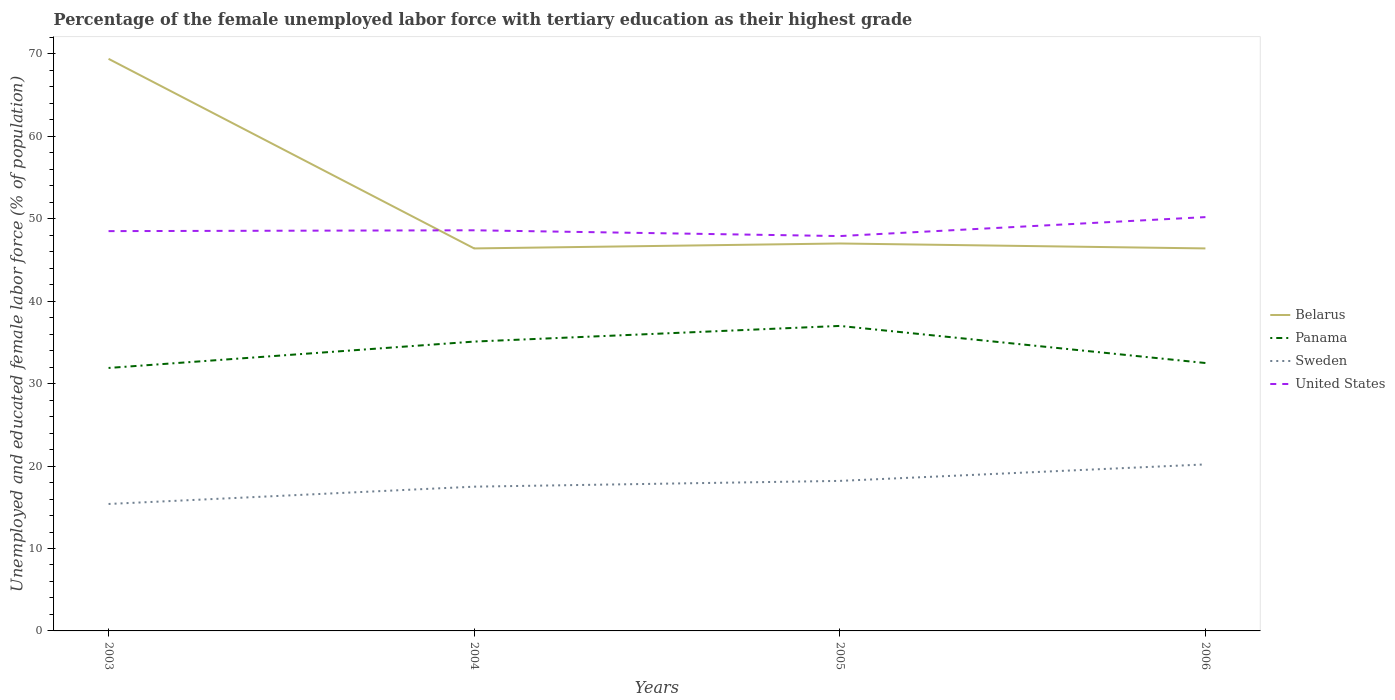How many different coloured lines are there?
Give a very brief answer. 4. Is the number of lines equal to the number of legend labels?
Make the answer very short. Yes. Across all years, what is the maximum percentage of the unemployed female labor force with tertiary education in United States?
Offer a terse response. 47.9. In which year was the percentage of the unemployed female labor force with tertiary education in Belarus maximum?
Your answer should be compact. 2004. What is the total percentage of the unemployed female labor force with tertiary education in Sweden in the graph?
Keep it short and to the point. -0.7. What is the difference between the highest and the second highest percentage of the unemployed female labor force with tertiary education in United States?
Make the answer very short. 2.3. What is the difference between the highest and the lowest percentage of the unemployed female labor force with tertiary education in Panama?
Your response must be concise. 2. Is the percentage of the unemployed female labor force with tertiary education in United States strictly greater than the percentage of the unemployed female labor force with tertiary education in Belarus over the years?
Your response must be concise. No. How many lines are there?
Offer a very short reply. 4. What is the difference between two consecutive major ticks on the Y-axis?
Your answer should be very brief. 10. Are the values on the major ticks of Y-axis written in scientific E-notation?
Keep it short and to the point. No. Does the graph contain any zero values?
Your answer should be compact. No. How are the legend labels stacked?
Ensure brevity in your answer.  Vertical. What is the title of the graph?
Your answer should be compact. Percentage of the female unemployed labor force with tertiary education as their highest grade. Does "Botswana" appear as one of the legend labels in the graph?
Your answer should be very brief. No. What is the label or title of the X-axis?
Keep it short and to the point. Years. What is the label or title of the Y-axis?
Make the answer very short. Unemployed and educated female labor force (% of population). What is the Unemployed and educated female labor force (% of population) of Belarus in 2003?
Provide a short and direct response. 69.4. What is the Unemployed and educated female labor force (% of population) of Panama in 2003?
Provide a short and direct response. 31.9. What is the Unemployed and educated female labor force (% of population) in Sweden in 2003?
Your answer should be very brief. 15.4. What is the Unemployed and educated female labor force (% of population) of United States in 2003?
Offer a terse response. 48.5. What is the Unemployed and educated female labor force (% of population) in Belarus in 2004?
Keep it short and to the point. 46.4. What is the Unemployed and educated female labor force (% of population) of Panama in 2004?
Provide a short and direct response. 35.1. What is the Unemployed and educated female labor force (% of population) of Sweden in 2004?
Your answer should be very brief. 17.5. What is the Unemployed and educated female labor force (% of population) of United States in 2004?
Ensure brevity in your answer.  48.6. What is the Unemployed and educated female labor force (% of population) of Panama in 2005?
Keep it short and to the point. 37. What is the Unemployed and educated female labor force (% of population) in Sweden in 2005?
Provide a short and direct response. 18.2. What is the Unemployed and educated female labor force (% of population) in United States in 2005?
Offer a very short reply. 47.9. What is the Unemployed and educated female labor force (% of population) in Belarus in 2006?
Provide a succinct answer. 46.4. What is the Unemployed and educated female labor force (% of population) in Panama in 2006?
Ensure brevity in your answer.  32.5. What is the Unemployed and educated female labor force (% of population) of Sweden in 2006?
Your answer should be compact. 20.2. What is the Unemployed and educated female labor force (% of population) of United States in 2006?
Ensure brevity in your answer.  50.2. Across all years, what is the maximum Unemployed and educated female labor force (% of population) of Belarus?
Your answer should be very brief. 69.4. Across all years, what is the maximum Unemployed and educated female labor force (% of population) of Panama?
Provide a succinct answer. 37. Across all years, what is the maximum Unemployed and educated female labor force (% of population) in Sweden?
Your answer should be very brief. 20.2. Across all years, what is the maximum Unemployed and educated female labor force (% of population) in United States?
Give a very brief answer. 50.2. Across all years, what is the minimum Unemployed and educated female labor force (% of population) of Belarus?
Your answer should be compact. 46.4. Across all years, what is the minimum Unemployed and educated female labor force (% of population) in Panama?
Make the answer very short. 31.9. Across all years, what is the minimum Unemployed and educated female labor force (% of population) of Sweden?
Make the answer very short. 15.4. Across all years, what is the minimum Unemployed and educated female labor force (% of population) in United States?
Provide a short and direct response. 47.9. What is the total Unemployed and educated female labor force (% of population) in Belarus in the graph?
Your answer should be very brief. 209.2. What is the total Unemployed and educated female labor force (% of population) of Panama in the graph?
Give a very brief answer. 136.5. What is the total Unemployed and educated female labor force (% of population) in Sweden in the graph?
Your answer should be very brief. 71.3. What is the total Unemployed and educated female labor force (% of population) of United States in the graph?
Give a very brief answer. 195.2. What is the difference between the Unemployed and educated female labor force (% of population) in Panama in 2003 and that in 2004?
Your response must be concise. -3.2. What is the difference between the Unemployed and educated female labor force (% of population) in United States in 2003 and that in 2004?
Provide a succinct answer. -0.1. What is the difference between the Unemployed and educated female labor force (% of population) in Belarus in 2003 and that in 2005?
Ensure brevity in your answer.  22.4. What is the difference between the Unemployed and educated female labor force (% of population) of Panama in 2003 and that in 2005?
Your response must be concise. -5.1. What is the difference between the Unemployed and educated female labor force (% of population) of Panama in 2003 and that in 2006?
Your answer should be compact. -0.6. What is the difference between the Unemployed and educated female labor force (% of population) in Sweden in 2003 and that in 2006?
Make the answer very short. -4.8. What is the difference between the Unemployed and educated female labor force (% of population) in United States in 2003 and that in 2006?
Keep it short and to the point. -1.7. What is the difference between the Unemployed and educated female labor force (% of population) of Belarus in 2004 and that in 2005?
Provide a short and direct response. -0.6. What is the difference between the Unemployed and educated female labor force (% of population) in Panama in 2004 and that in 2005?
Provide a short and direct response. -1.9. What is the difference between the Unemployed and educated female labor force (% of population) in Sweden in 2004 and that in 2005?
Your response must be concise. -0.7. What is the difference between the Unemployed and educated female labor force (% of population) of United States in 2004 and that in 2005?
Offer a terse response. 0.7. What is the difference between the Unemployed and educated female labor force (% of population) in Belarus in 2004 and that in 2006?
Ensure brevity in your answer.  0. What is the difference between the Unemployed and educated female labor force (% of population) in United States in 2004 and that in 2006?
Keep it short and to the point. -1.6. What is the difference between the Unemployed and educated female labor force (% of population) in Panama in 2005 and that in 2006?
Provide a succinct answer. 4.5. What is the difference between the Unemployed and educated female labor force (% of population) in Belarus in 2003 and the Unemployed and educated female labor force (% of population) in Panama in 2004?
Keep it short and to the point. 34.3. What is the difference between the Unemployed and educated female labor force (% of population) of Belarus in 2003 and the Unemployed and educated female labor force (% of population) of Sweden in 2004?
Make the answer very short. 51.9. What is the difference between the Unemployed and educated female labor force (% of population) of Belarus in 2003 and the Unemployed and educated female labor force (% of population) of United States in 2004?
Offer a very short reply. 20.8. What is the difference between the Unemployed and educated female labor force (% of population) of Panama in 2003 and the Unemployed and educated female labor force (% of population) of Sweden in 2004?
Offer a very short reply. 14.4. What is the difference between the Unemployed and educated female labor force (% of population) in Panama in 2003 and the Unemployed and educated female labor force (% of population) in United States in 2004?
Your answer should be compact. -16.7. What is the difference between the Unemployed and educated female labor force (% of population) in Sweden in 2003 and the Unemployed and educated female labor force (% of population) in United States in 2004?
Offer a very short reply. -33.2. What is the difference between the Unemployed and educated female labor force (% of population) in Belarus in 2003 and the Unemployed and educated female labor force (% of population) in Panama in 2005?
Provide a short and direct response. 32.4. What is the difference between the Unemployed and educated female labor force (% of population) in Belarus in 2003 and the Unemployed and educated female labor force (% of population) in Sweden in 2005?
Your answer should be very brief. 51.2. What is the difference between the Unemployed and educated female labor force (% of population) of Belarus in 2003 and the Unemployed and educated female labor force (% of population) of United States in 2005?
Your answer should be very brief. 21.5. What is the difference between the Unemployed and educated female labor force (% of population) of Sweden in 2003 and the Unemployed and educated female labor force (% of population) of United States in 2005?
Provide a short and direct response. -32.5. What is the difference between the Unemployed and educated female labor force (% of population) of Belarus in 2003 and the Unemployed and educated female labor force (% of population) of Panama in 2006?
Provide a short and direct response. 36.9. What is the difference between the Unemployed and educated female labor force (% of population) of Belarus in 2003 and the Unemployed and educated female labor force (% of population) of Sweden in 2006?
Give a very brief answer. 49.2. What is the difference between the Unemployed and educated female labor force (% of population) of Panama in 2003 and the Unemployed and educated female labor force (% of population) of Sweden in 2006?
Offer a very short reply. 11.7. What is the difference between the Unemployed and educated female labor force (% of population) in Panama in 2003 and the Unemployed and educated female labor force (% of population) in United States in 2006?
Your response must be concise. -18.3. What is the difference between the Unemployed and educated female labor force (% of population) in Sweden in 2003 and the Unemployed and educated female labor force (% of population) in United States in 2006?
Your response must be concise. -34.8. What is the difference between the Unemployed and educated female labor force (% of population) of Belarus in 2004 and the Unemployed and educated female labor force (% of population) of Panama in 2005?
Your answer should be compact. 9.4. What is the difference between the Unemployed and educated female labor force (% of population) in Belarus in 2004 and the Unemployed and educated female labor force (% of population) in Sweden in 2005?
Provide a short and direct response. 28.2. What is the difference between the Unemployed and educated female labor force (% of population) of Belarus in 2004 and the Unemployed and educated female labor force (% of population) of United States in 2005?
Offer a terse response. -1.5. What is the difference between the Unemployed and educated female labor force (% of population) in Panama in 2004 and the Unemployed and educated female labor force (% of population) in United States in 2005?
Keep it short and to the point. -12.8. What is the difference between the Unemployed and educated female labor force (% of population) in Sweden in 2004 and the Unemployed and educated female labor force (% of population) in United States in 2005?
Your answer should be compact. -30.4. What is the difference between the Unemployed and educated female labor force (% of population) in Belarus in 2004 and the Unemployed and educated female labor force (% of population) in Panama in 2006?
Provide a short and direct response. 13.9. What is the difference between the Unemployed and educated female labor force (% of population) of Belarus in 2004 and the Unemployed and educated female labor force (% of population) of Sweden in 2006?
Ensure brevity in your answer.  26.2. What is the difference between the Unemployed and educated female labor force (% of population) in Belarus in 2004 and the Unemployed and educated female labor force (% of population) in United States in 2006?
Ensure brevity in your answer.  -3.8. What is the difference between the Unemployed and educated female labor force (% of population) of Panama in 2004 and the Unemployed and educated female labor force (% of population) of Sweden in 2006?
Your response must be concise. 14.9. What is the difference between the Unemployed and educated female labor force (% of population) of Panama in 2004 and the Unemployed and educated female labor force (% of population) of United States in 2006?
Your answer should be compact. -15.1. What is the difference between the Unemployed and educated female labor force (% of population) of Sweden in 2004 and the Unemployed and educated female labor force (% of population) of United States in 2006?
Give a very brief answer. -32.7. What is the difference between the Unemployed and educated female labor force (% of population) of Belarus in 2005 and the Unemployed and educated female labor force (% of population) of Sweden in 2006?
Offer a terse response. 26.8. What is the difference between the Unemployed and educated female labor force (% of population) of Panama in 2005 and the Unemployed and educated female labor force (% of population) of Sweden in 2006?
Your response must be concise. 16.8. What is the difference between the Unemployed and educated female labor force (% of population) in Sweden in 2005 and the Unemployed and educated female labor force (% of population) in United States in 2006?
Offer a terse response. -32. What is the average Unemployed and educated female labor force (% of population) of Belarus per year?
Ensure brevity in your answer.  52.3. What is the average Unemployed and educated female labor force (% of population) in Panama per year?
Provide a short and direct response. 34.12. What is the average Unemployed and educated female labor force (% of population) of Sweden per year?
Offer a very short reply. 17.82. What is the average Unemployed and educated female labor force (% of population) in United States per year?
Give a very brief answer. 48.8. In the year 2003, what is the difference between the Unemployed and educated female labor force (% of population) of Belarus and Unemployed and educated female labor force (% of population) of Panama?
Offer a terse response. 37.5. In the year 2003, what is the difference between the Unemployed and educated female labor force (% of population) in Belarus and Unemployed and educated female labor force (% of population) in Sweden?
Your answer should be compact. 54. In the year 2003, what is the difference between the Unemployed and educated female labor force (% of population) of Belarus and Unemployed and educated female labor force (% of population) of United States?
Offer a very short reply. 20.9. In the year 2003, what is the difference between the Unemployed and educated female labor force (% of population) in Panama and Unemployed and educated female labor force (% of population) in Sweden?
Make the answer very short. 16.5. In the year 2003, what is the difference between the Unemployed and educated female labor force (% of population) in Panama and Unemployed and educated female labor force (% of population) in United States?
Ensure brevity in your answer.  -16.6. In the year 2003, what is the difference between the Unemployed and educated female labor force (% of population) of Sweden and Unemployed and educated female labor force (% of population) of United States?
Ensure brevity in your answer.  -33.1. In the year 2004, what is the difference between the Unemployed and educated female labor force (% of population) of Belarus and Unemployed and educated female labor force (% of population) of Sweden?
Make the answer very short. 28.9. In the year 2004, what is the difference between the Unemployed and educated female labor force (% of population) in Belarus and Unemployed and educated female labor force (% of population) in United States?
Your response must be concise. -2.2. In the year 2004, what is the difference between the Unemployed and educated female labor force (% of population) of Panama and Unemployed and educated female labor force (% of population) of Sweden?
Offer a terse response. 17.6. In the year 2004, what is the difference between the Unemployed and educated female labor force (% of population) in Sweden and Unemployed and educated female labor force (% of population) in United States?
Offer a very short reply. -31.1. In the year 2005, what is the difference between the Unemployed and educated female labor force (% of population) of Belarus and Unemployed and educated female labor force (% of population) of Panama?
Offer a very short reply. 10. In the year 2005, what is the difference between the Unemployed and educated female labor force (% of population) in Belarus and Unemployed and educated female labor force (% of population) in Sweden?
Your answer should be compact. 28.8. In the year 2005, what is the difference between the Unemployed and educated female labor force (% of population) in Sweden and Unemployed and educated female labor force (% of population) in United States?
Your response must be concise. -29.7. In the year 2006, what is the difference between the Unemployed and educated female labor force (% of population) in Belarus and Unemployed and educated female labor force (% of population) in Panama?
Offer a terse response. 13.9. In the year 2006, what is the difference between the Unemployed and educated female labor force (% of population) of Belarus and Unemployed and educated female labor force (% of population) of Sweden?
Give a very brief answer. 26.2. In the year 2006, what is the difference between the Unemployed and educated female labor force (% of population) in Belarus and Unemployed and educated female labor force (% of population) in United States?
Your answer should be very brief. -3.8. In the year 2006, what is the difference between the Unemployed and educated female labor force (% of population) of Panama and Unemployed and educated female labor force (% of population) of Sweden?
Your response must be concise. 12.3. In the year 2006, what is the difference between the Unemployed and educated female labor force (% of population) in Panama and Unemployed and educated female labor force (% of population) in United States?
Make the answer very short. -17.7. What is the ratio of the Unemployed and educated female labor force (% of population) of Belarus in 2003 to that in 2004?
Give a very brief answer. 1.5. What is the ratio of the Unemployed and educated female labor force (% of population) in Panama in 2003 to that in 2004?
Offer a terse response. 0.91. What is the ratio of the Unemployed and educated female labor force (% of population) of Sweden in 2003 to that in 2004?
Provide a short and direct response. 0.88. What is the ratio of the Unemployed and educated female labor force (% of population) in Belarus in 2003 to that in 2005?
Offer a very short reply. 1.48. What is the ratio of the Unemployed and educated female labor force (% of population) in Panama in 2003 to that in 2005?
Your response must be concise. 0.86. What is the ratio of the Unemployed and educated female labor force (% of population) of Sweden in 2003 to that in 2005?
Make the answer very short. 0.85. What is the ratio of the Unemployed and educated female labor force (% of population) in United States in 2003 to that in 2005?
Make the answer very short. 1.01. What is the ratio of the Unemployed and educated female labor force (% of population) of Belarus in 2003 to that in 2006?
Your answer should be very brief. 1.5. What is the ratio of the Unemployed and educated female labor force (% of population) of Panama in 2003 to that in 2006?
Ensure brevity in your answer.  0.98. What is the ratio of the Unemployed and educated female labor force (% of population) of Sweden in 2003 to that in 2006?
Give a very brief answer. 0.76. What is the ratio of the Unemployed and educated female labor force (% of population) of United States in 2003 to that in 2006?
Keep it short and to the point. 0.97. What is the ratio of the Unemployed and educated female labor force (% of population) in Belarus in 2004 to that in 2005?
Provide a succinct answer. 0.99. What is the ratio of the Unemployed and educated female labor force (% of population) of Panama in 2004 to that in 2005?
Ensure brevity in your answer.  0.95. What is the ratio of the Unemployed and educated female labor force (% of population) in Sweden in 2004 to that in 2005?
Give a very brief answer. 0.96. What is the ratio of the Unemployed and educated female labor force (% of population) in United States in 2004 to that in 2005?
Offer a very short reply. 1.01. What is the ratio of the Unemployed and educated female labor force (% of population) of Belarus in 2004 to that in 2006?
Provide a short and direct response. 1. What is the ratio of the Unemployed and educated female labor force (% of population) in Sweden in 2004 to that in 2006?
Your answer should be very brief. 0.87. What is the ratio of the Unemployed and educated female labor force (% of population) in United States in 2004 to that in 2006?
Provide a succinct answer. 0.97. What is the ratio of the Unemployed and educated female labor force (% of population) in Belarus in 2005 to that in 2006?
Provide a succinct answer. 1.01. What is the ratio of the Unemployed and educated female labor force (% of population) in Panama in 2005 to that in 2006?
Your response must be concise. 1.14. What is the ratio of the Unemployed and educated female labor force (% of population) of Sweden in 2005 to that in 2006?
Ensure brevity in your answer.  0.9. What is the ratio of the Unemployed and educated female labor force (% of population) in United States in 2005 to that in 2006?
Ensure brevity in your answer.  0.95. What is the difference between the highest and the second highest Unemployed and educated female labor force (% of population) in Belarus?
Keep it short and to the point. 22.4. What is the difference between the highest and the second highest Unemployed and educated female labor force (% of population) in Panama?
Your answer should be very brief. 1.9. What is the difference between the highest and the second highest Unemployed and educated female labor force (% of population) in United States?
Keep it short and to the point. 1.6. What is the difference between the highest and the lowest Unemployed and educated female labor force (% of population) of Sweden?
Your answer should be very brief. 4.8. What is the difference between the highest and the lowest Unemployed and educated female labor force (% of population) of United States?
Offer a terse response. 2.3. 